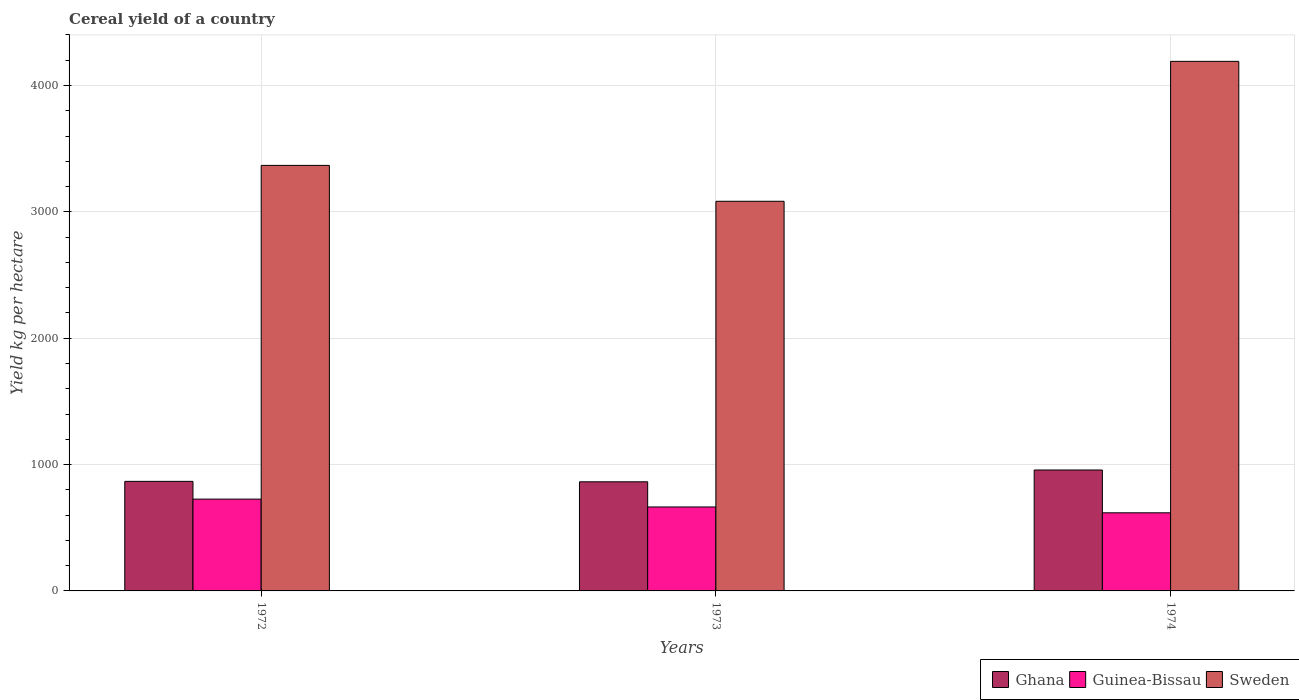Are the number of bars per tick equal to the number of legend labels?
Keep it short and to the point. Yes. Are the number of bars on each tick of the X-axis equal?
Give a very brief answer. Yes. How many bars are there on the 3rd tick from the left?
Offer a very short reply. 3. What is the total cereal yield in Guinea-Bissau in 1973?
Provide a succinct answer. 664.47. Across all years, what is the maximum total cereal yield in Sweden?
Your answer should be very brief. 4191.39. Across all years, what is the minimum total cereal yield in Sweden?
Give a very brief answer. 3083.99. In which year was the total cereal yield in Sweden maximum?
Give a very brief answer. 1974. What is the total total cereal yield in Guinea-Bissau in the graph?
Keep it short and to the point. 2009.37. What is the difference between the total cereal yield in Ghana in 1972 and that in 1973?
Your response must be concise. 3.41. What is the difference between the total cereal yield in Sweden in 1974 and the total cereal yield in Guinea-Bissau in 1972?
Your answer should be very brief. 3464.77. What is the average total cereal yield in Ghana per year?
Keep it short and to the point. 895.96. In the year 1973, what is the difference between the total cereal yield in Ghana and total cereal yield in Sweden?
Provide a short and direct response. -2220.31. What is the ratio of the total cereal yield in Guinea-Bissau in 1973 to that in 1974?
Keep it short and to the point. 1.07. Is the total cereal yield in Guinea-Bissau in 1972 less than that in 1974?
Provide a short and direct response. No. Is the difference between the total cereal yield in Ghana in 1972 and 1974 greater than the difference between the total cereal yield in Sweden in 1972 and 1974?
Provide a short and direct response. Yes. What is the difference between the highest and the second highest total cereal yield in Guinea-Bissau?
Your response must be concise. 62.14. What is the difference between the highest and the lowest total cereal yield in Guinea-Bissau?
Provide a short and direct response. 108.34. In how many years, is the total cereal yield in Sweden greater than the average total cereal yield in Sweden taken over all years?
Offer a very short reply. 1. Is the sum of the total cereal yield in Ghana in 1972 and 1973 greater than the maximum total cereal yield in Guinea-Bissau across all years?
Your answer should be compact. Yes. What does the 1st bar from the left in 1972 represents?
Provide a short and direct response. Ghana. What does the 3rd bar from the right in 1973 represents?
Offer a very short reply. Ghana. Are all the bars in the graph horizontal?
Your answer should be compact. No. How are the legend labels stacked?
Your answer should be compact. Horizontal. What is the title of the graph?
Provide a succinct answer. Cereal yield of a country. Does "Slovak Republic" appear as one of the legend labels in the graph?
Keep it short and to the point. No. What is the label or title of the Y-axis?
Offer a very short reply. Yield kg per hectare. What is the Yield kg per hectare in Ghana in 1972?
Your response must be concise. 867.09. What is the Yield kg per hectare in Guinea-Bissau in 1972?
Keep it short and to the point. 726.62. What is the Yield kg per hectare in Sweden in 1972?
Your answer should be very brief. 3368.02. What is the Yield kg per hectare in Ghana in 1973?
Keep it short and to the point. 863.68. What is the Yield kg per hectare in Guinea-Bissau in 1973?
Your answer should be very brief. 664.47. What is the Yield kg per hectare in Sweden in 1973?
Provide a succinct answer. 3083.99. What is the Yield kg per hectare in Ghana in 1974?
Ensure brevity in your answer.  957.1. What is the Yield kg per hectare of Guinea-Bissau in 1974?
Keep it short and to the point. 618.28. What is the Yield kg per hectare in Sweden in 1974?
Provide a succinct answer. 4191.39. Across all years, what is the maximum Yield kg per hectare of Ghana?
Keep it short and to the point. 957.1. Across all years, what is the maximum Yield kg per hectare in Guinea-Bissau?
Offer a very short reply. 726.62. Across all years, what is the maximum Yield kg per hectare in Sweden?
Provide a succinct answer. 4191.39. Across all years, what is the minimum Yield kg per hectare of Ghana?
Give a very brief answer. 863.68. Across all years, what is the minimum Yield kg per hectare in Guinea-Bissau?
Offer a terse response. 618.28. Across all years, what is the minimum Yield kg per hectare of Sweden?
Make the answer very short. 3083.99. What is the total Yield kg per hectare of Ghana in the graph?
Your response must be concise. 2687.87. What is the total Yield kg per hectare of Guinea-Bissau in the graph?
Keep it short and to the point. 2009.37. What is the total Yield kg per hectare of Sweden in the graph?
Make the answer very short. 1.06e+04. What is the difference between the Yield kg per hectare of Ghana in 1972 and that in 1973?
Provide a succinct answer. 3.41. What is the difference between the Yield kg per hectare of Guinea-Bissau in 1972 and that in 1973?
Provide a short and direct response. 62.15. What is the difference between the Yield kg per hectare in Sweden in 1972 and that in 1973?
Give a very brief answer. 284.03. What is the difference between the Yield kg per hectare of Ghana in 1972 and that in 1974?
Your answer should be very brief. -90.01. What is the difference between the Yield kg per hectare of Guinea-Bissau in 1972 and that in 1974?
Offer a very short reply. 108.34. What is the difference between the Yield kg per hectare in Sweden in 1972 and that in 1974?
Give a very brief answer. -823.37. What is the difference between the Yield kg per hectare of Ghana in 1973 and that in 1974?
Keep it short and to the point. -93.41. What is the difference between the Yield kg per hectare of Guinea-Bissau in 1973 and that in 1974?
Provide a succinct answer. 46.19. What is the difference between the Yield kg per hectare in Sweden in 1973 and that in 1974?
Keep it short and to the point. -1107.4. What is the difference between the Yield kg per hectare in Ghana in 1972 and the Yield kg per hectare in Guinea-Bissau in 1973?
Offer a terse response. 202.62. What is the difference between the Yield kg per hectare in Ghana in 1972 and the Yield kg per hectare in Sweden in 1973?
Your answer should be very brief. -2216.9. What is the difference between the Yield kg per hectare in Guinea-Bissau in 1972 and the Yield kg per hectare in Sweden in 1973?
Your answer should be compact. -2357.37. What is the difference between the Yield kg per hectare in Ghana in 1972 and the Yield kg per hectare in Guinea-Bissau in 1974?
Your answer should be very brief. 248.81. What is the difference between the Yield kg per hectare of Ghana in 1972 and the Yield kg per hectare of Sweden in 1974?
Keep it short and to the point. -3324.3. What is the difference between the Yield kg per hectare of Guinea-Bissau in 1972 and the Yield kg per hectare of Sweden in 1974?
Keep it short and to the point. -3464.77. What is the difference between the Yield kg per hectare in Ghana in 1973 and the Yield kg per hectare in Guinea-Bissau in 1974?
Keep it short and to the point. 245.4. What is the difference between the Yield kg per hectare in Ghana in 1973 and the Yield kg per hectare in Sweden in 1974?
Your answer should be very brief. -3327.71. What is the difference between the Yield kg per hectare of Guinea-Bissau in 1973 and the Yield kg per hectare of Sweden in 1974?
Make the answer very short. -3526.92. What is the average Yield kg per hectare of Ghana per year?
Give a very brief answer. 895.96. What is the average Yield kg per hectare in Guinea-Bissau per year?
Offer a very short reply. 669.79. What is the average Yield kg per hectare in Sweden per year?
Your answer should be compact. 3547.8. In the year 1972, what is the difference between the Yield kg per hectare in Ghana and Yield kg per hectare in Guinea-Bissau?
Provide a short and direct response. 140.47. In the year 1972, what is the difference between the Yield kg per hectare in Ghana and Yield kg per hectare in Sweden?
Offer a terse response. -2500.93. In the year 1972, what is the difference between the Yield kg per hectare in Guinea-Bissau and Yield kg per hectare in Sweden?
Your answer should be very brief. -2641.4. In the year 1973, what is the difference between the Yield kg per hectare in Ghana and Yield kg per hectare in Guinea-Bissau?
Keep it short and to the point. 199.21. In the year 1973, what is the difference between the Yield kg per hectare in Ghana and Yield kg per hectare in Sweden?
Give a very brief answer. -2220.31. In the year 1973, what is the difference between the Yield kg per hectare of Guinea-Bissau and Yield kg per hectare of Sweden?
Your response must be concise. -2419.52. In the year 1974, what is the difference between the Yield kg per hectare of Ghana and Yield kg per hectare of Guinea-Bissau?
Keep it short and to the point. 338.82. In the year 1974, what is the difference between the Yield kg per hectare in Ghana and Yield kg per hectare in Sweden?
Keep it short and to the point. -3234.3. In the year 1974, what is the difference between the Yield kg per hectare in Guinea-Bissau and Yield kg per hectare in Sweden?
Offer a terse response. -3573.11. What is the ratio of the Yield kg per hectare of Ghana in 1972 to that in 1973?
Make the answer very short. 1. What is the ratio of the Yield kg per hectare in Guinea-Bissau in 1972 to that in 1973?
Provide a short and direct response. 1.09. What is the ratio of the Yield kg per hectare of Sweden in 1972 to that in 1973?
Provide a short and direct response. 1.09. What is the ratio of the Yield kg per hectare of Ghana in 1972 to that in 1974?
Provide a succinct answer. 0.91. What is the ratio of the Yield kg per hectare in Guinea-Bissau in 1972 to that in 1974?
Your answer should be compact. 1.18. What is the ratio of the Yield kg per hectare in Sweden in 1972 to that in 1974?
Keep it short and to the point. 0.8. What is the ratio of the Yield kg per hectare in Ghana in 1973 to that in 1974?
Ensure brevity in your answer.  0.9. What is the ratio of the Yield kg per hectare of Guinea-Bissau in 1973 to that in 1974?
Give a very brief answer. 1.07. What is the ratio of the Yield kg per hectare in Sweden in 1973 to that in 1974?
Your response must be concise. 0.74. What is the difference between the highest and the second highest Yield kg per hectare in Ghana?
Offer a very short reply. 90.01. What is the difference between the highest and the second highest Yield kg per hectare in Guinea-Bissau?
Keep it short and to the point. 62.15. What is the difference between the highest and the second highest Yield kg per hectare of Sweden?
Your response must be concise. 823.37. What is the difference between the highest and the lowest Yield kg per hectare in Ghana?
Provide a succinct answer. 93.41. What is the difference between the highest and the lowest Yield kg per hectare of Guinea-Bissau?
Your answer should be very brief. 108.34. What is the difference between the highest and the lowest Yield kg per hectare in Sweden?
Ensure brevity in your answer.  1107.4. 